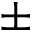<formula> <loc_0><loc_0><loc_500><loc_500>\pm</formula> 